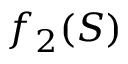Convert formula to latex. <formula><loc_0><loc_0><loc_500><loc_500>f _ { 2 } ( S )</formula> 